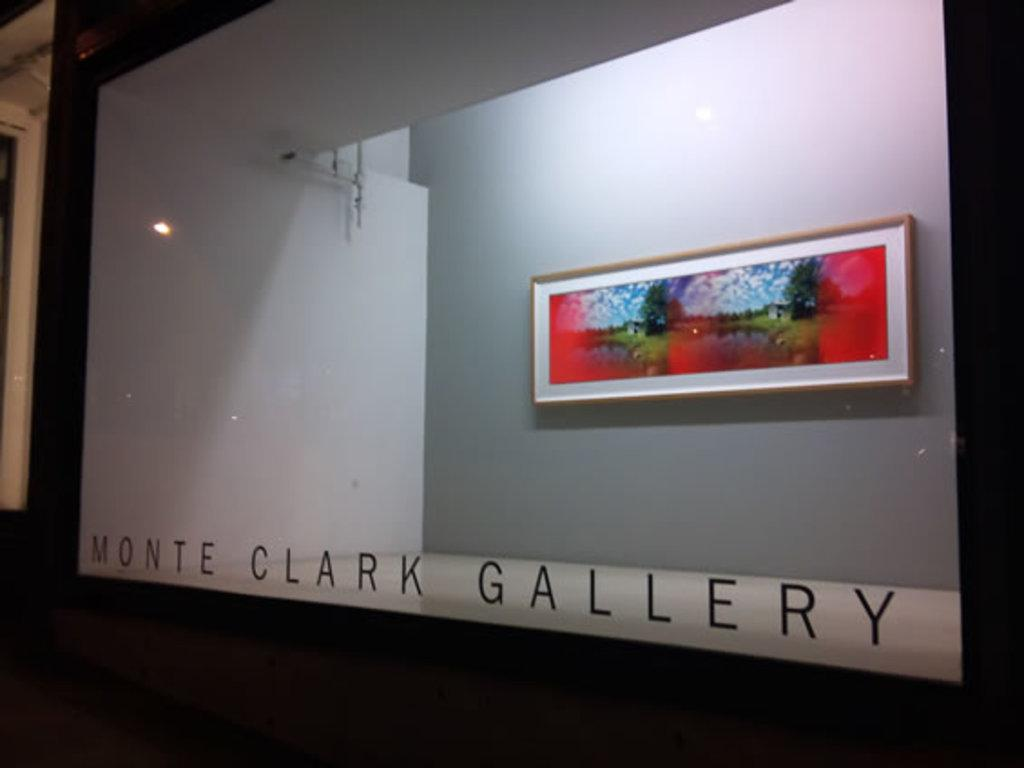<image>
Present a compact description of the photo's key features. A painting is set back against the wall in a glass enclosed display at Monte Clark Gallery. 